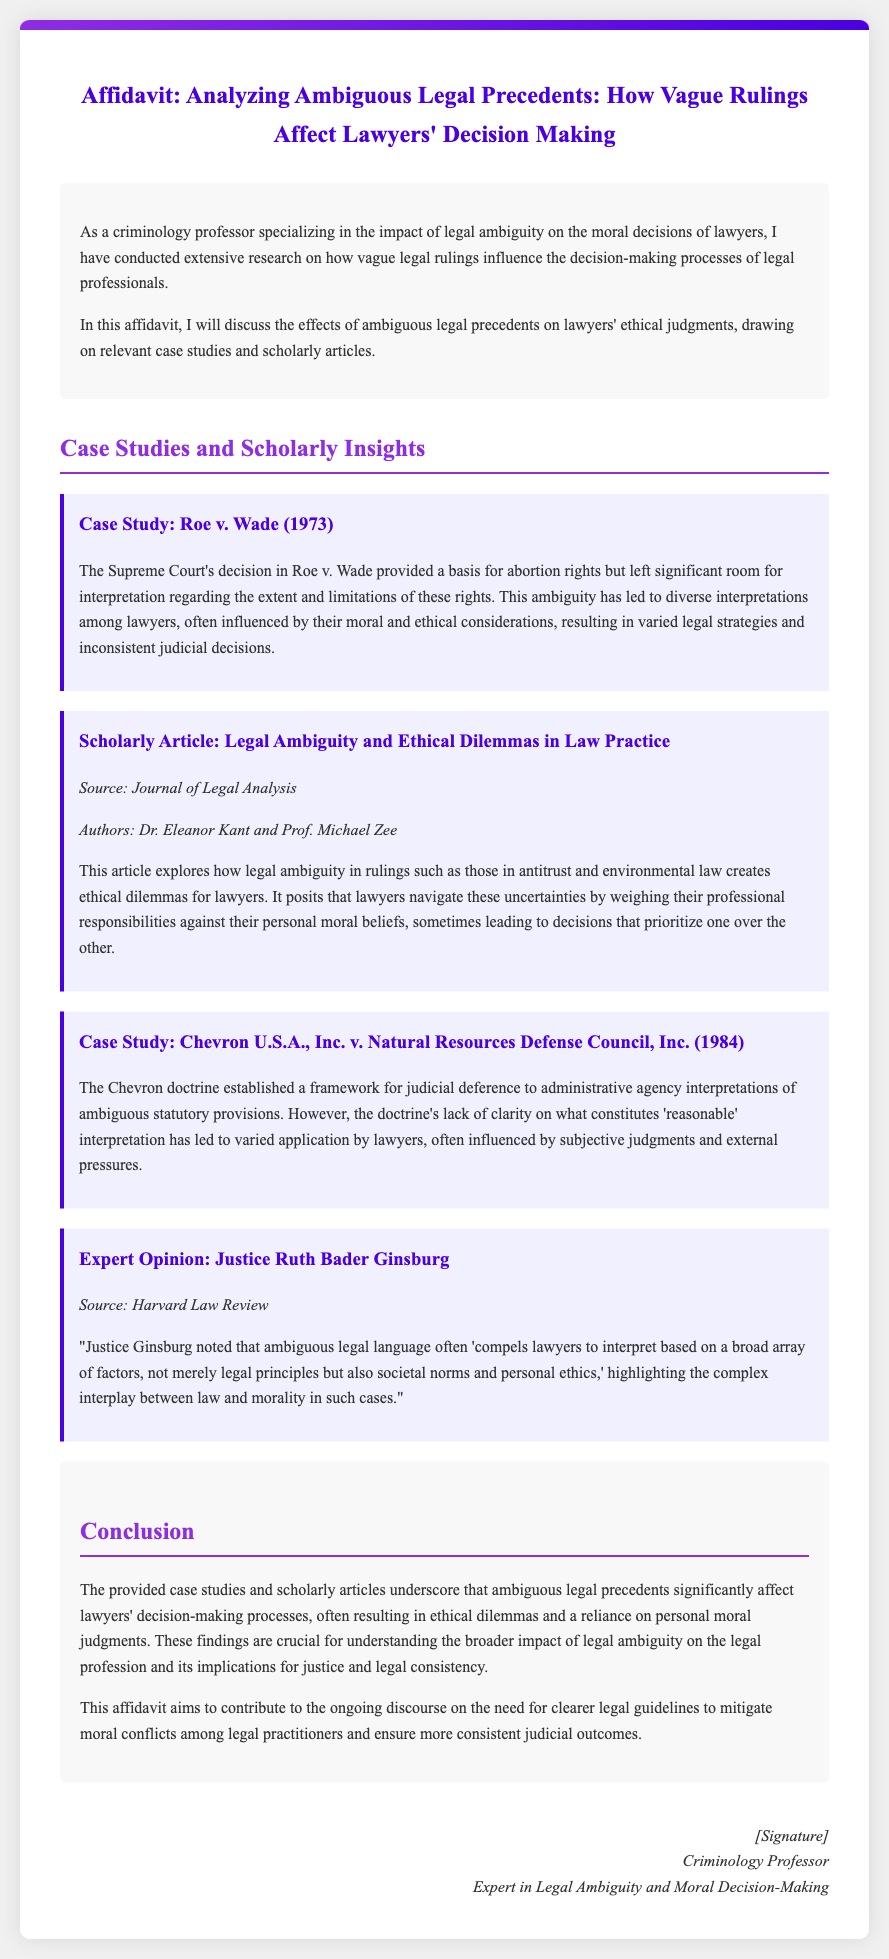What is the title of the affidavit? The title of the affidavit summarizes its focus on ambiguous legal precedents and their effects on lawyers' decision-making.
Answer: Affidavit: Analyzing Ambiguous Legal Precedents: How Vague Rulings Affect Lawyers' Decision Making Who conducted the research discussed in the affidavit? The researcher is identified as a criminology professor specializing in legal ambiguity and its impact on moral decisions of lawyers.
Answer: A criminology professor What year was Roe v. Wade decided? The year mentioned in the case study corresponds to the landmark ruling that established a basis for abortion rights.
Answer: 1973 What is the main conclusion drawn in the affidavit? The conclusion discusses the impact of ambiguous legal precedents on lawyers' ethical dilemmas and decision-making processes.
Answer: Ambiguous legal precedents significantly affect lawyers’ decision-making processes Which case study discusses judicial deference to administrative agency interpretations? The case study highlights a legal framework established for administrative agency interpretations and its impact on lawyers' practices.
Answer: Chevron U.S.A., Inc. v. Natural Resources Defense Council, Inc. (1984) What is the source of the scholarly article mentioned in the affidavit? The document references a specific journal where the article on legal ambiguity and ethical dilemmas was published.
Answer: Journal of Legal Analysis What did Justice Ruth Bader Ginsburg emphasize regarding legal language? The expert opinion explains the complexities lawyers face when interpreting ambiguous legal language, stressing a broader context.
Answer: Ambiguous legal language often 'compels lawyers to interpret based on a broad array of factors' What two aspects do lawyers have to weigh according to the discussed article? The article posits that lawyers confront a balance between their professional responsibilities and personal moral beliefs in their decision-making.
Answer: Professional responsibilities and personal moral beliefs 